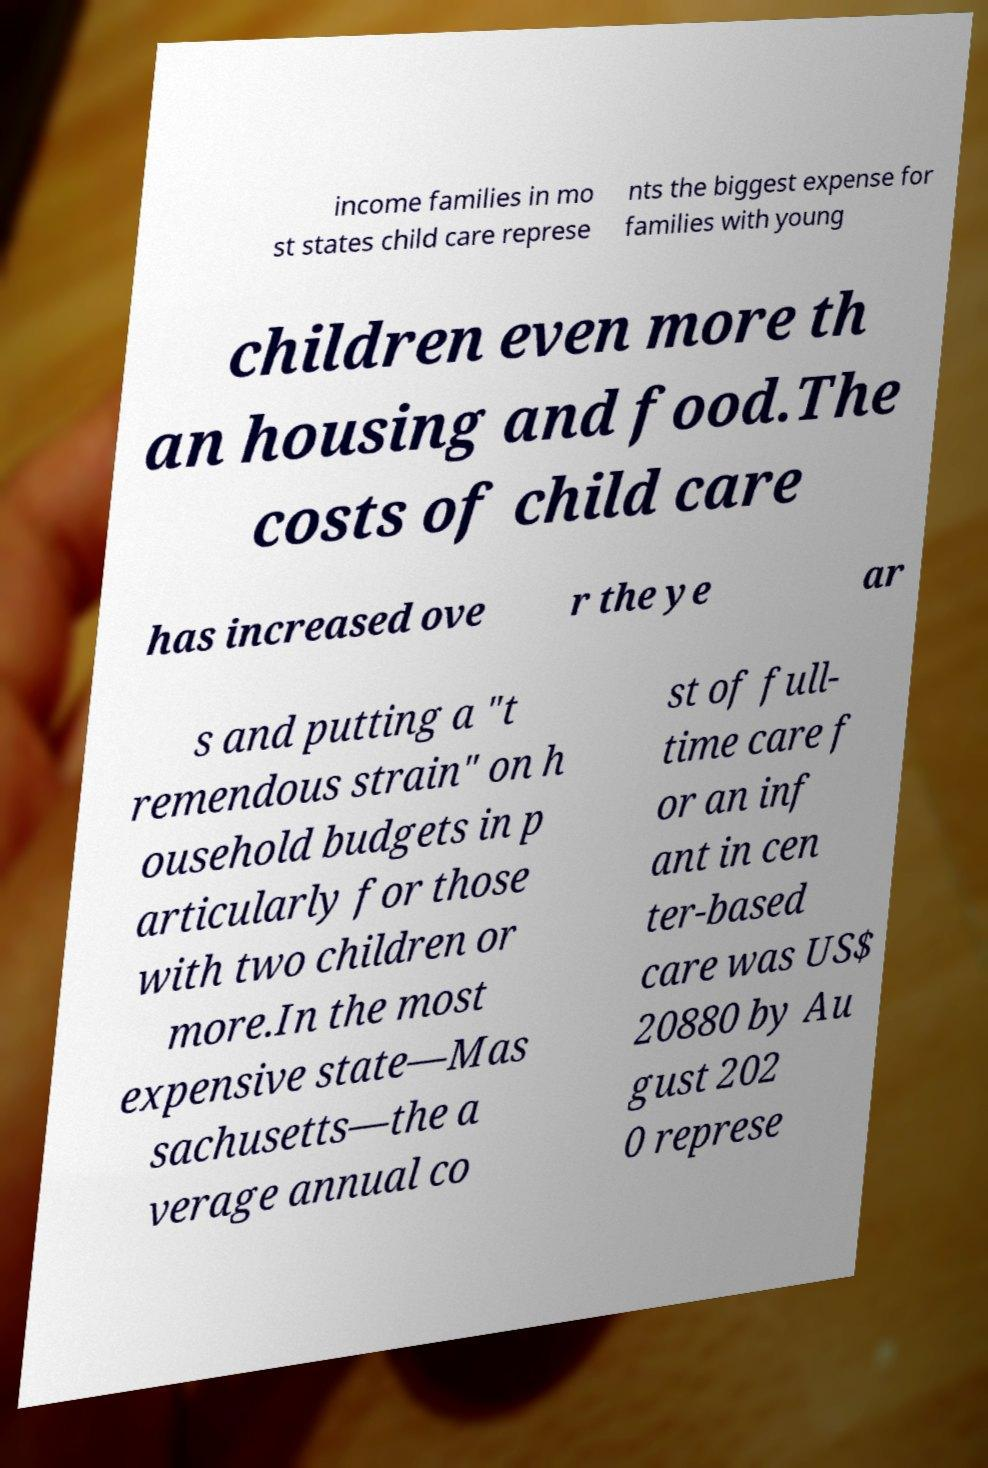For documentation purposes, I need the text within this image transcribed. Could you provide that? income families in mo st states child care represe nts the biggest expense for families with young children even more th an housing and food.The costs of child care has increased ove r the ye ar s and putting a "t remendous strain" on h ousehold budgets in p articularly for those with two children or more.In the most expensive state—Mas sachusetts—the a verage annual co st of full- time care f or an inf ant in cen ter-based care was US$ 20880 by Au gust 202 0 represe 